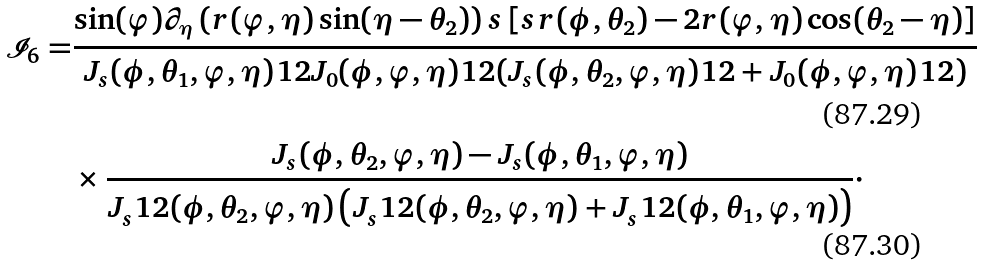Convert formula to latex. <formula><loc_0><loc_0><loc_500><loc_500>\mathcal { I } _ { 6 } = & \frac { \sin ( \varphi ) \partial _ { \eta } \left ( r ( \varphi , \eta ) \sin ( \eta - \theta _ { 2 } ) \right ) s \left [ s r ( \phi , \theta _ { 2 } ) - 2 r ( \varphi , \eta ) \cos ( \theta _ { 2 } - \eta ) \right ] } { J _ { s } ( \phi , \theta _ { 1 } , \varphi , \eta ) ^ { } { 1 } 2 J _ { 0 } ( \phi , \varphi , \eta ) ^ { } { 1 } 2 ( J _ { s } ( \phi , \theta _ { 2 } , \varphi , \eta ) ^ { } { 1 } 2 + J _ { 0 } ( \phi , \varphi , \eta ) ^ { } { 1 } 2 ) } \\ & \times \frac { J _ { s } ( \phi , \theta _ { 2 } , \varphi , \eta ) - J _ { s } ( \phi , \theta _ { 1 } , \varphi , \eta ) } { J _ { s } ^ { } { 1 } 2 ( \phi , \theta _ { 2 } , \varphi , \eta ) \left ( J _ { s } ^ { } { 1 } 2 ( \phi , \theta _ { 2 } , \varphi , \eta ) + J _ { s } ^ { } { 1 } 2 ( \phi , \theta _ { 1 } , \varphi , \eta ) \right ) } \cdot</formula> 